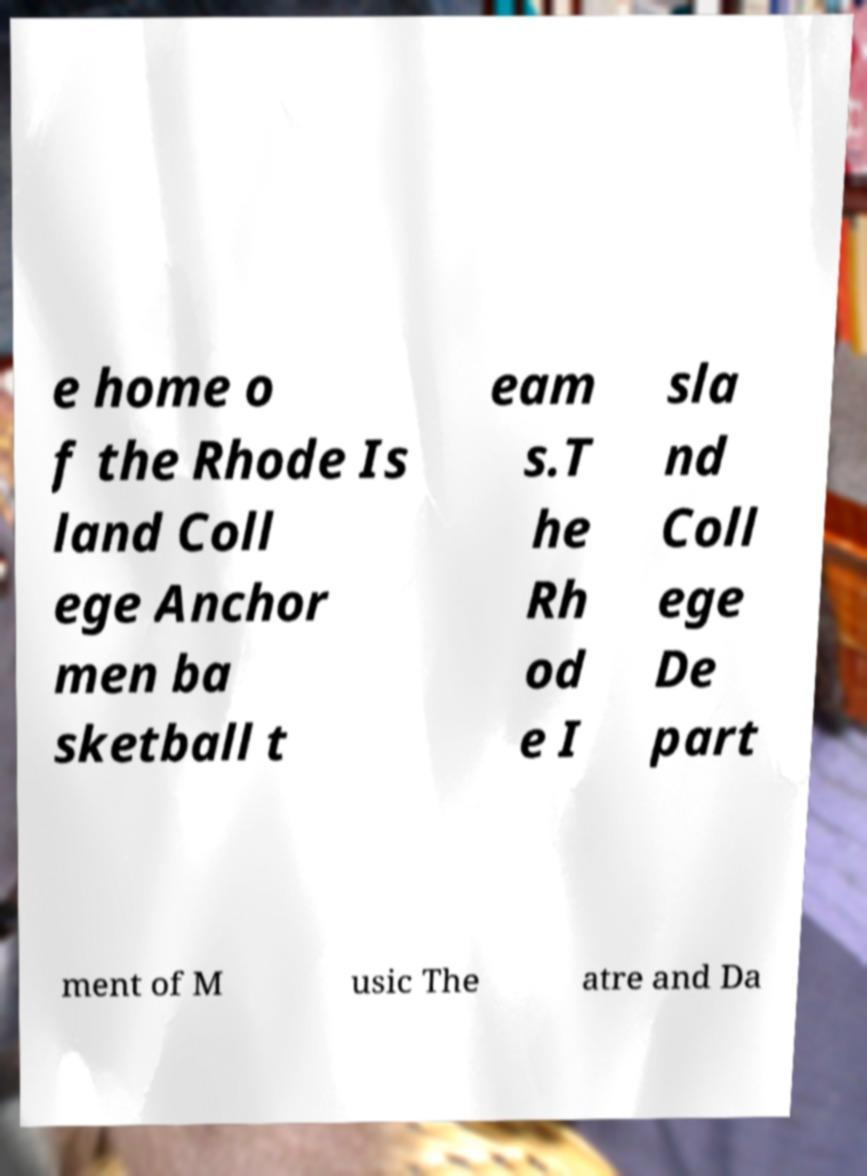Can you accurately transcribe the text from the provided image for me? e home o f the Rhode Is land Coll ege Anchor men ba sketball t eam s.T he Rh od e I sla nd Coll ege De part ment of M usic The atre and Da 